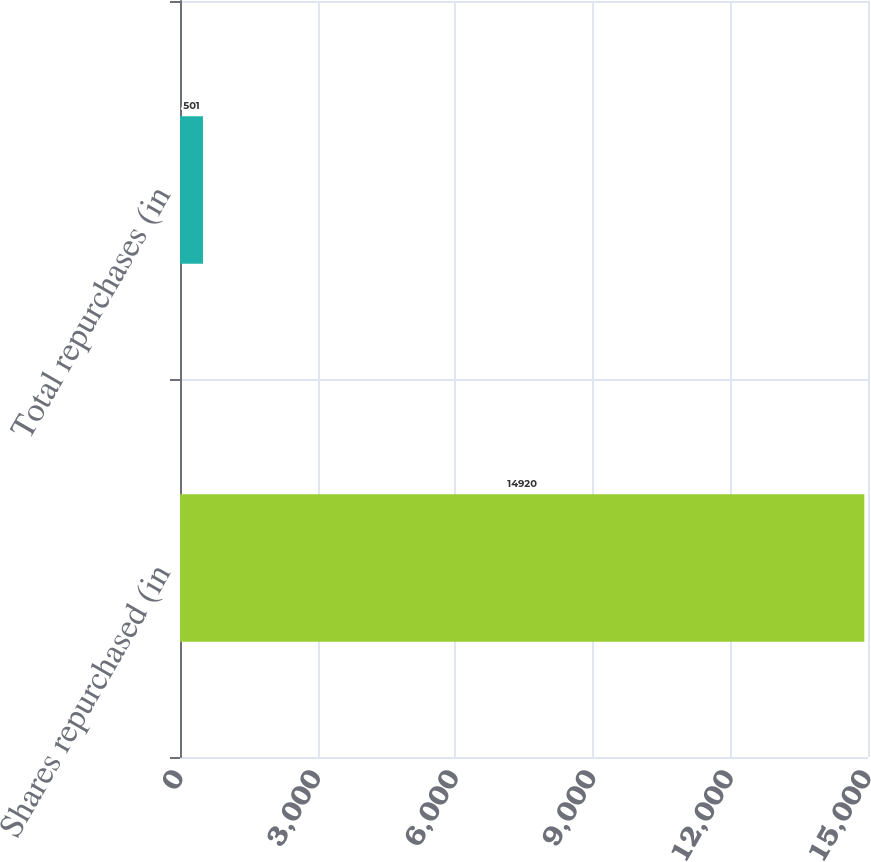<chart> <loc_0><loc_0><loc_500><loc_500><bar_chart><fcel>Shares repurchased (in<fcel>Total repurchases (in<nl><fcel>14920<fcel>501<nl></chart> 